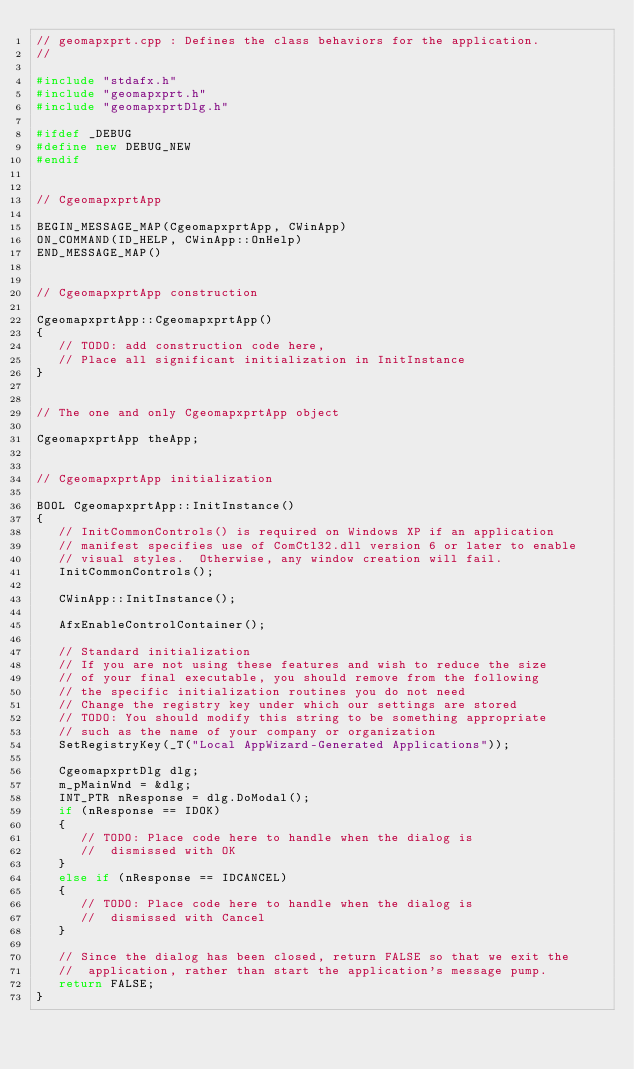Convert code to text. <code><loc_0><loc_0><loc_500><loc_500><_C++_>// geomapxprt.cpp : Defines the class behaviors for the application.
//

#include "stdafx.h"
#include "geomapxprt.h"
#include "geomapxprtDlg.h"

#ifdef _DEBUG
#define new DEBUG_NEW
#endif


// CgeomapxprtApp

BEGIN_MESSAGE_MAP(CgeomapxprtApp, CWinApp)
ON_COMMAND(ID_HELP, CWinApp::OnHelp)
END_MESSAGE_MAP()


// CgeomapxprtApp construction

CgeomapxprtApp::CgeomapxprtApp()
{
   // TODO: add construction code here,
   // Place all significant initialization in InitInstance
}


// The one and only CgeomapxprtApp object

CgeomapxprtApp theApp;


// CgeomapxprtApp initialization

BOOL CgeomapxprtApp::InitInstance()
{
   // InitCommonControls() is required on Windows XP if an application
   // manifest specifies use of ComCtl32.dll version 6 or later to enable
   // visual styles.  Otherwise, any window creation will fail.
   InitCommonControls();

   CWinApp::InitInstance();

   AfxEnableControlContainer();

   // Standard initialization
   // If you are not using these features and wish to reduce the size
   // of your final executable, you should remove from the following
   // the specific initialization routines you do not need
   // Change the registry key under which our settings are stored
   // TODO: You should modify this string to be something appropriate
   // such as the name of your company or organization
   SetRegistryKey(_T("Local AppWizard-Generated Applications"));

   CgeomapxprtDlg dlg;
   m_pMainWnd = &dlg;
   INT_PTR nResponse = dlg.DoModal();
   if (nResponse == IDOK)
   {
      // TODO: Place code here to handle when the dialog is
      //  dismissed with OK
   }
   else if (nResponse == IDCANCEL)
   {
      // TODO: Place code here to handle when the dialog is
      //  dismissed with Cancel
   }

   // Since the dialog has been closed, return FALSE so that we exit the
   //  application, rather than start the application's message pump.
   return FALSE;
}
</code> 